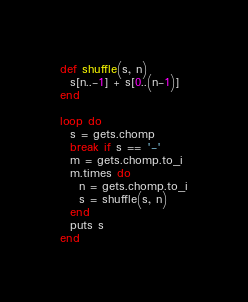<code> <loc_0><loc_0><loc_500><loc_500><_Ruby_>def shuffle(s, n)
  s[n..-1] + s[0..(n-1)]
end

loop do
  s = gets.chomp
  break if s == '-'
  m = gets.chomp.to_i
  m.times do
    n = gets.chomp.to_i
    s = shuffle(s, n)
  end
  puts s
end</code> 